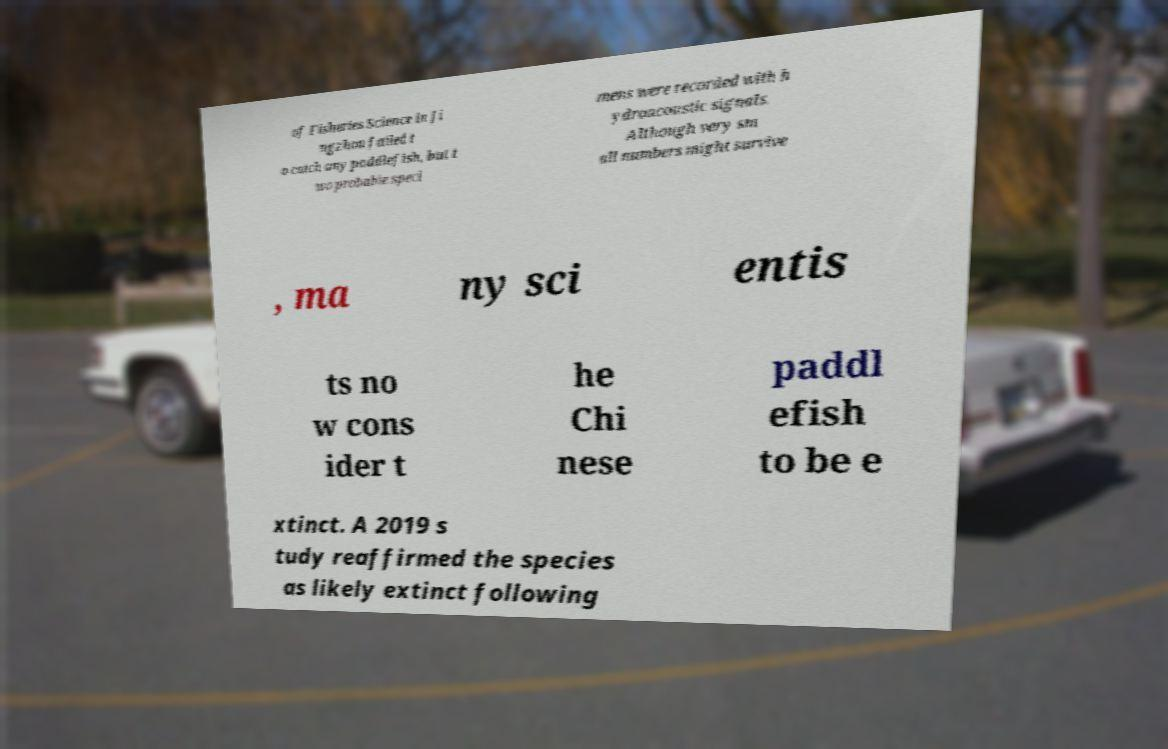There's text embedded in this image that I need extracted. Can you transcribe it verbatim? of Fisheries Science in Ji ngzhou failed t o catch any paddlefish, but t wo probable speci mens were recorded with h ydroacoustic signals. Although very sm all numbers might survive , ma ny sci entis ts no w cons ider t he Chi nese paddl efish to be e xtinct. A 2019 s tudy reaffirmed the species as likely extinct following 